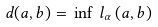Convert formula to latex. <formula><loc_0><loc_0><loc_500><loc_500>d ( a , b ) = \, \inf \, l _ { \alpha } \left ( a , b \right )</formula> 